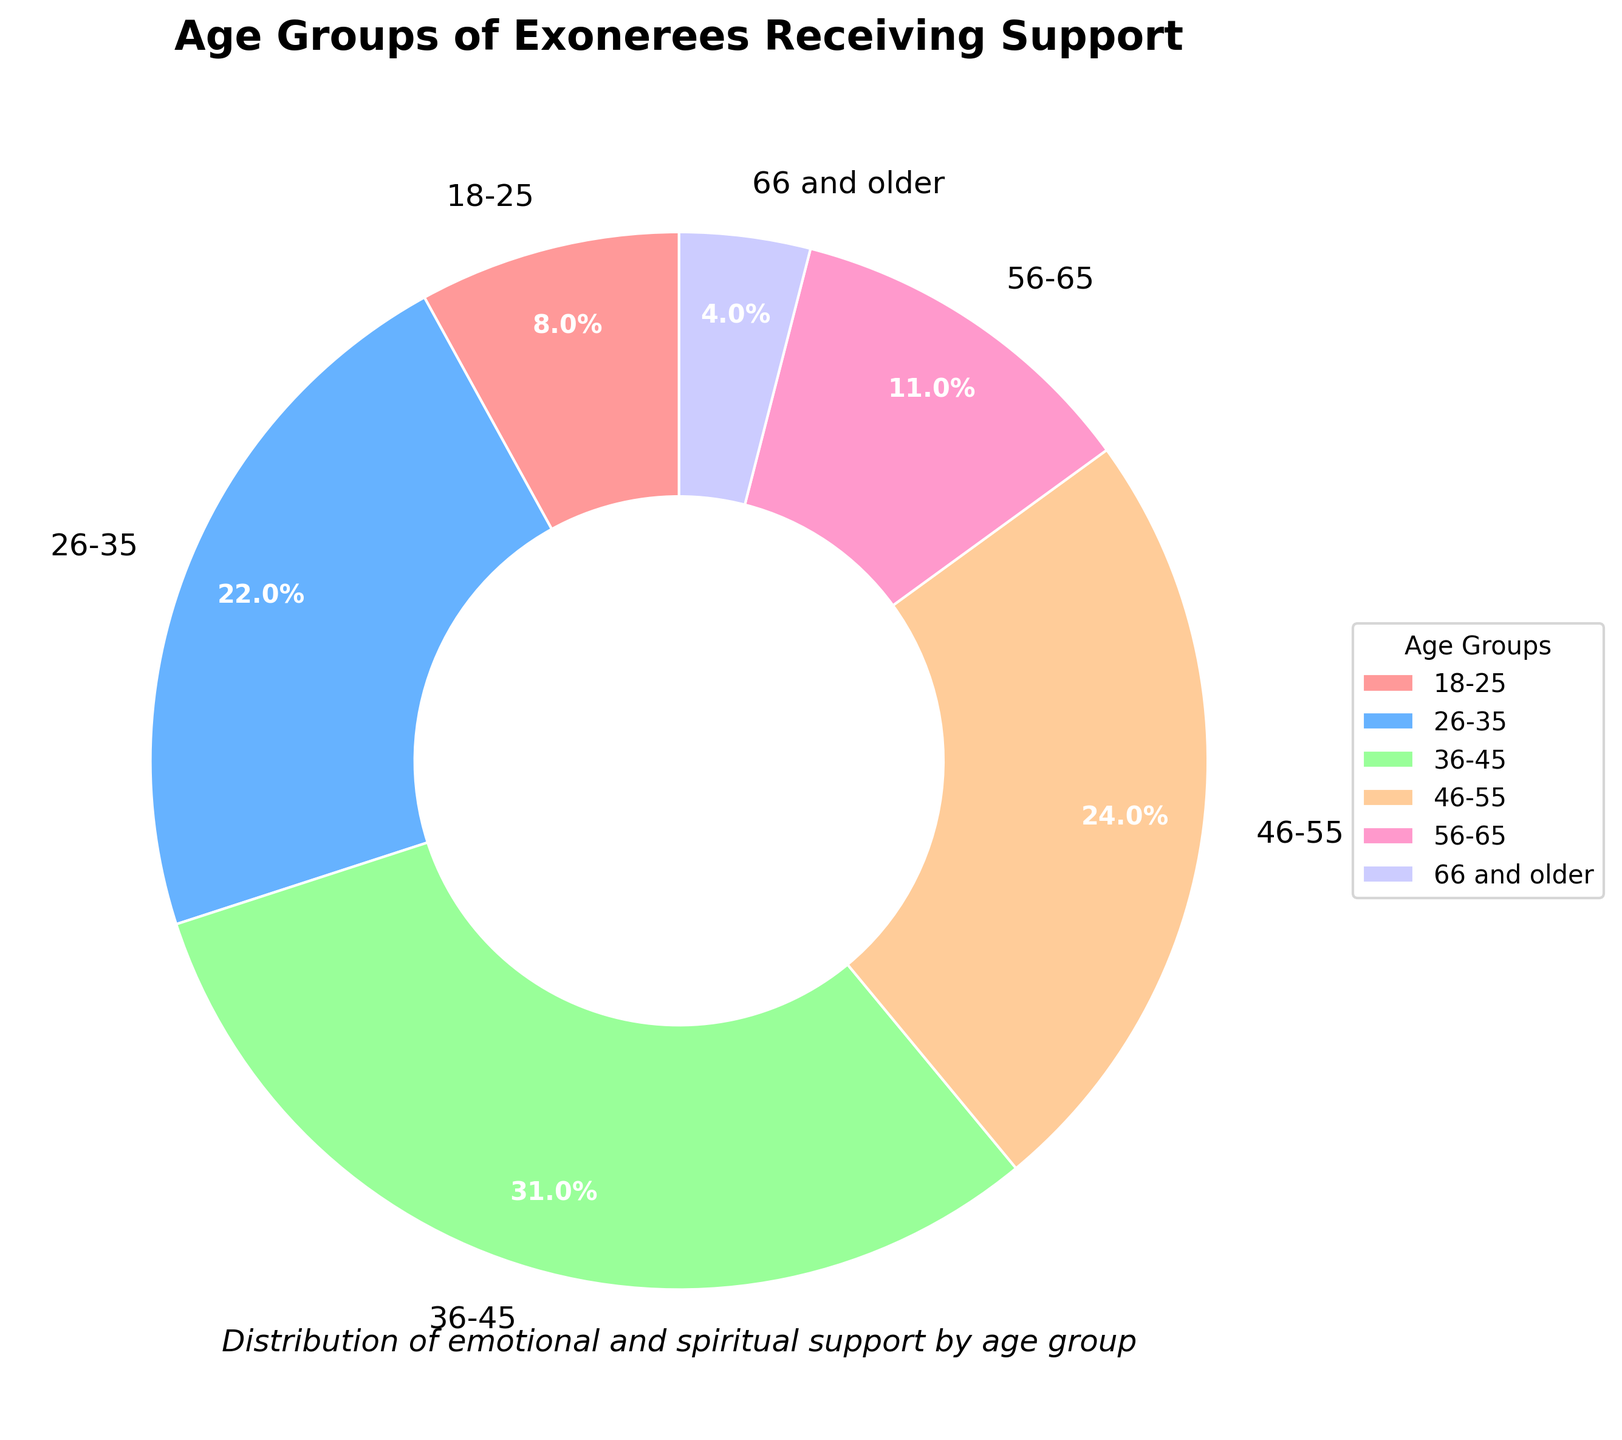What age group has the highest percentage of exonerees receiving support? The largest wedge in the pie chart signifies the age group with the highest percentage. By looking at the figure, the `36-45` age group has the largest wedge.
Answer: 36-45 What is the combined percentage of exonerees aged 26-35 and 46-55? Look at the pie chart and find the percentages for the `26-35` and `46-55` age groups. Sum these percentages: 22% (26-35) + 24% (46-55) = 46%.
Answer: 46% Is the percentage of exonerees receiving support who are aged 56-65 greater than those aged 18-25? Compare the sizes of the labels for the `56-65` and `18-25` age groups. The `56-65` age group is 11%, and the `18-25` age group is 8%. 11% is indeed greater than 8%.
Answer: Yes Which age group has the smallest percentage of exonerees receiving support, and what is that percentage? Find the wedge with the smallest size in the pie chart, which represents the `66 and older` age group. The label shows this group has a percentage of 4%.
Answer: 66 and older, 4% How many age groups have a percentage of 10% or more? Count the number of wedges in the pie chart with percentages that are greater than or equal to 10%. The age groups `18-25` (8%) does not qualify, but `26-35` (22%), `36-45` (31%), `46-55` (24%), and `56-65` (11%) do, giving us four age groups in total.
Answer: 4 What is the difference in the percentage between the youngest (18-25) and the oldest (66 and older) age groups? Look at the chart to find the percentages for the `18-25` and `66 and older` age groups. Subtract these values: 8% (18-25) - 4% (66 and older) = 4%.
Answer: 4% What percentage of the total do the combined groups 36-45 and 46-55 constitute? Identify and sum the percentages for `36-45` and `46-55`: 31% (36-45) + 24% (46-55) = 55%.
Answer: 55% Which color represents the age group 26-35, and what is the percentage for this age group? Look at the color of the wedge labeled `26-35` in the pie chart. The color is `blue`, and the percentage is shown as 22%.
Answer: Blue, 22% If the age groups 46-55 and 56-65 are combined, would their total percentage be greater than the group 36-45? Calculate the combined percentage for `46-55` and `56-65`: 24% (46-55) + 11% (56-65) = 35%. Since 35% is greater than 31%, the combined percentage is greater.
Answer: Yes What is the average percentage of the age groups 18-25, 46-55, and 56-65? Sum the percentages for the `18-25`, `46-55`, and `56-65` groups: 8% + 24% + 11% = 43%. Divide by the number of groups, which is 3. 43% / 3 = approx. 14.3%.
Answer: 14.3% 